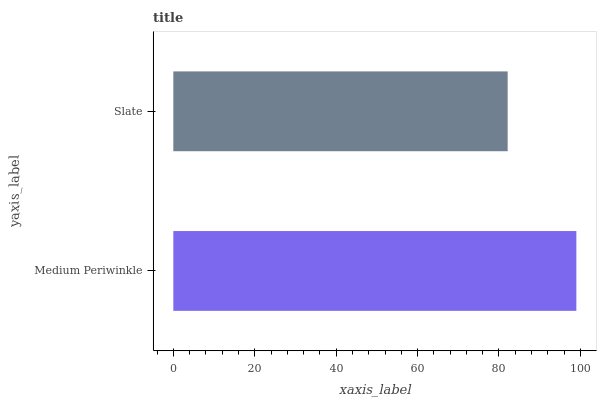Is Slate the minimum?
Answer yes or no. Yes. Is Medium Periwinkle the maximum?
Answer yes or no. Yes. Is Slate the maximum?
Answer yes or no. No. Is Medium Periwinkle greater than Slate?
Answer yes or no. Yes. Is Slate less than Medium Periwinkle?
Answer yes or no. Yes. Is Slate greater than Medium Periwinkle?
Answer yes or no. No. Is Medium Periwinkle less than Slate?
Answer yes or no. No. Is Medium Periwinkle the high median?
Answer yes or no. Yes. Is Slate the low median?
Answer yes or no. Yes. Is Slate the high median?
Answer yes or no. No. Is Medium Periwinkle the low median?
Answer yes or no. No. 